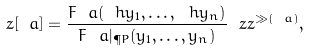Convert formula to latex. <formula><loc_0><loc_0><loc_500><loc_500>z [ \ a ] = \frac { F _ { \ } a ( \ h y _ { 1 } , \dots , \ h y _ { n } ) } { F _ { \ } a | _ { \P P } ( y _ { 1 } , \dots , y _ { n } ) } \ z z ^ { \gg ( \ a ) } ,</formula> 